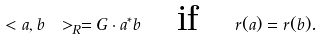<formula> <loc_0><loc_0><loc_500><loc_500>\ < a , b \ > _ { R } = G \cdot a ^ { * } b \quad \text {if} \quad r ( a ) = r ( b ) .</formula> 